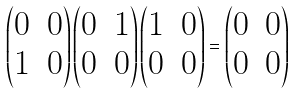<formula> <loc_0><loc_0><loc_500><loc_500>\begin{pmatrix} 0 & 0 \\ 1 & 0 \end{pmatrix} \begin{pmatrix} 0 & 1 \\ 0 & 0 \end{pmatrix} \begin{pmatrix} 1 & 0 \\ 0 & 0 \end{pmatrix} = \begin{pmatrix} 0 & 0 \\ 0 & 0 \end{pmatrix}</formula> 